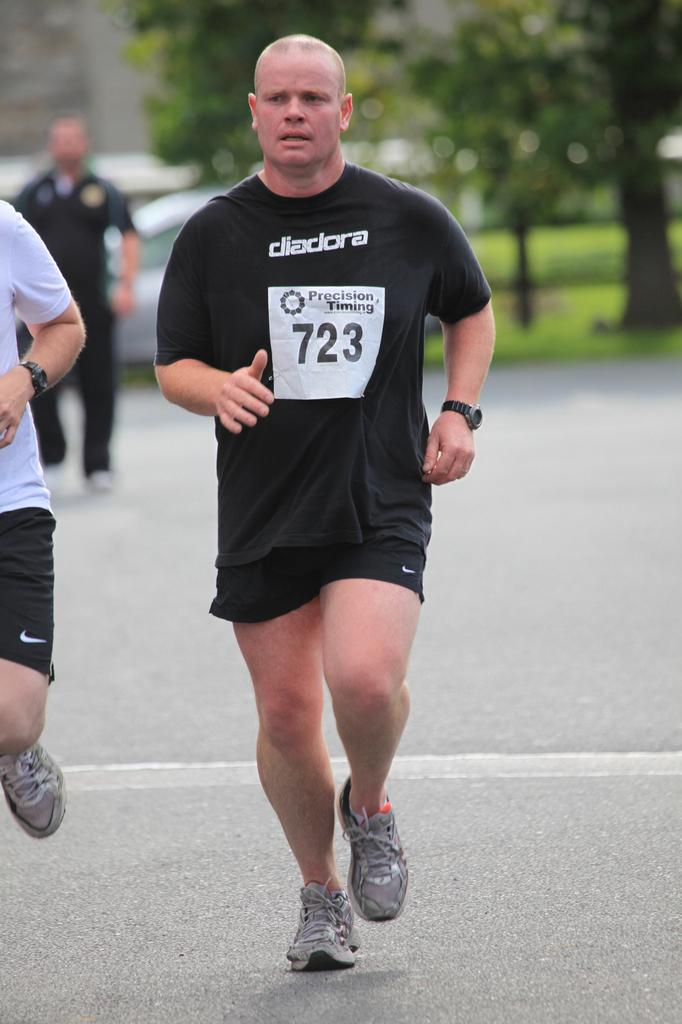How many people are in the image? There are three persons in the image. What are the persons doing in the image? The persons are running on a road. What can be seen in the background of the image? There are trees in the background of the image. How is the background of the image depicted? The background is blurred. Can you see a friend helping to tie a knot in the image? There is no friend or knot present in the image. 